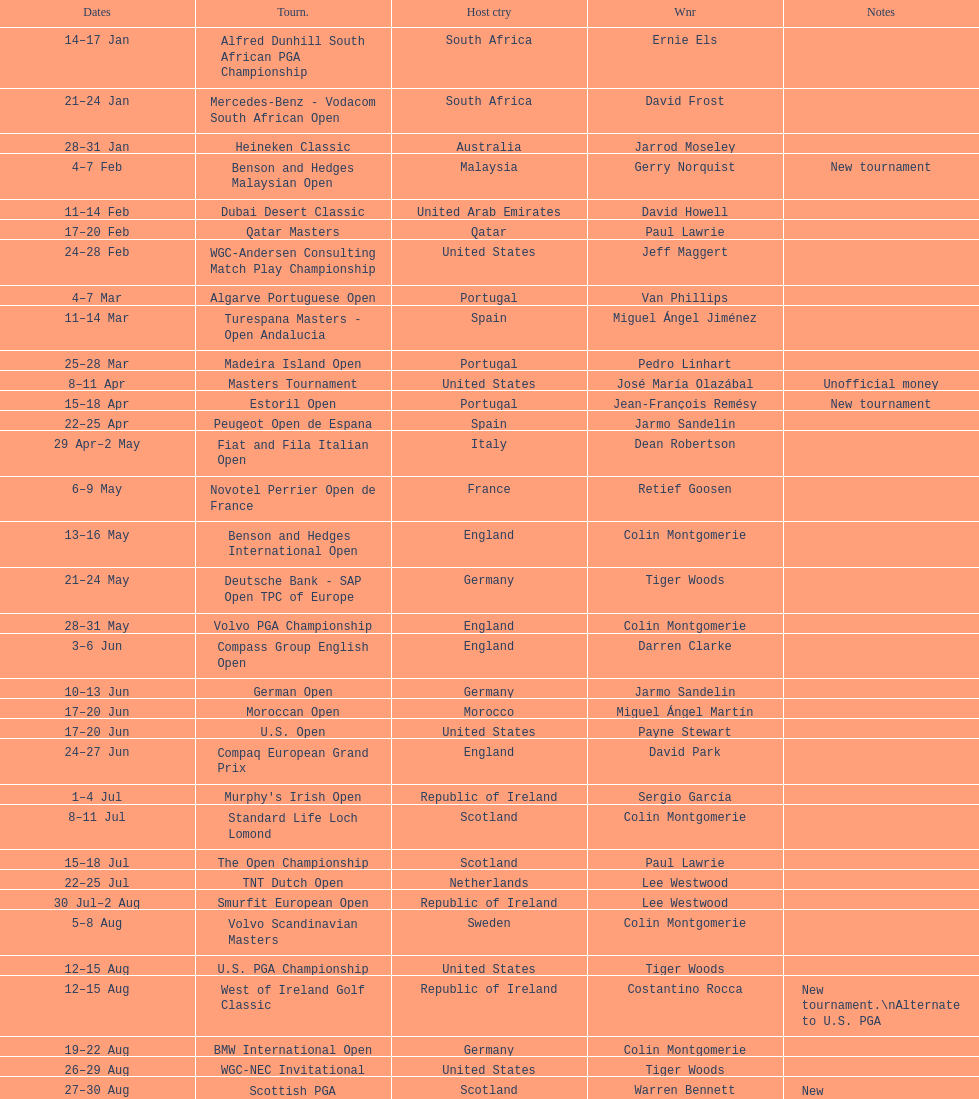Could you parse the entire table? {'header': ['Dates', 'Tourn.', 'Host ctry', 'Wnr', 'Notes'], 'rows': [['14–17\xa0Jan', 'Alfred Dunhill South African PGA Championship', 'South Africa', 'Ernie Els', ''], ['21–24\xa0Jan', 'Mercedes-Benz - Vodacom South African Open', 'South Africa', 'David Frost', ''], ['28–31\xa0Jan', 'Heineken Classic', 'Australia', 'Jarrod Moseley', ''], ['4–7\xa0Feb', 'Benson and Hedges Malaysian Open', 'Malaysia', 'Gerry Norquist', 'New tournament'], ['11–14\xa0Feb', 'Dubai Desert Classic', 'United Arab Emirates', 'David Howell', ''], ['17–20\xa0Feb', 'Qatar Masters', 'Qatar', 'Paul Lawrie', ''], ['24–28\xa0Feb', 'WGC-Andersen Consulting Match Play Championship', 'United States', 'Jeff Maggert', ''], ['4–7\xa0Mar', 'Algarve Portuguese Open', 'Portugal', 'Van Phillips', ''], ['11–14\xa0Mar', 'Turespana Masters - Open Andalucia', 'Spain', 'Miguel Ángel Jiménez', ''], ['25–28\xa0Mar', 'Madeira Island Open', 'Portugal', 'Pedro Linhart', ''], ['8–11\xa0Apr', 'Masters Tournament', 'United States', 'José María Olazábal', 'Unofficial money'], ['15–18\xa0Apr', 'Estoril Open', 'Portugal', 'Jean-François Remésy', 'New tournament'], ['22–25\xa0Apr', 'Peugeot Open de Espana', 'Spain', 'Jarmo Sandelin', ''], ['29\xa0Apr–2\xa0May', 'Fiat and Fila Italian Open', 'Italy', 'Dean Robertson', ''], ['6–9\xa0May', 'Novotel Perrier Open de France', 'France', 'Retief Goosen', ''], ['13–16\xa0May', 'Benson and Hedges International Open', 'England', 'Colin Montgomerie', ''], ['21–24\xa0May', 'Deutsche Bank - SAP Open TPC of Europe', 'Germany', 'Tiger Woods', ''], ['28–31\xa0May', 'Volvo PGA Championship', 'England', 'Colin Montgomerie', ''], ['3–6\xa0Jun', 'Compass Group English Open', 'England', 'Darren Clarke', ''], ['10–13\xa0Jun', 'German Open', 'Germany', 'Jarmo Sandelin', ''], ['17–20\xa0Jun', 'Moroccan Open', 'Morocco', 'Miguel Ángel Martín', ''], ['17–20\xa0Jun', 'U.S. Open', 'United States', 'Payne Stewart', ''], ['24–27\xa0Jun', 'Compaq European Grand Prix', 'England', 'David Park', ''], ['1–4\xa0Jul', "Murphy's Irish Open", 'Republic of Ireland', 'Sergio García', ''], ['8–11\xa0Jul', 'Standard Life Loch Lomond', 'Scotland', 'Colin Montgomerie', ''], ['15–18\xa0Jul', 'The Open Championship', 'Scotland', 'Paul Lawrie', ''], ['22–25\xa0Jul', 'TNT Dutch Open', 'Netherlands', 'Lee Westwood', ''], ['30\xa0Jul–2\xa0Aug', 'Smurfit European Open', 'Republic of Ireland', 'Lee Westwood', ''], ['5–8\xa0Aug', 'Volvo Scandinavian Masters', 'Sweden', 'Colin Montgomerie', ''], ['12–15\xa0Aug', 'U.S. PGA Championship', 'United States', 'Tiger Woods', ''], ['12–15\xa0Aug', 'West of Ireland Golf Classic', 'Republic of Ireland', 'Costantino Rocca', 'New tournament.\\nAlternate to U.S. PGA'], ['19–22\xa0Aug', 'BMW International Open', 'Germany', 'Colin Montgomerie', ''], ['26–29\xa0Aug', 'WGC-NEC Invitational', 'United States', 'Tiger Woods', ''], ['27–30\xa0Aug', 'Scottish PGA Championship', 'Scotland', 'Warren Bennett', 'New tournament.\\nAlternate to WGC'], ['2–5\xa0Sept', 'Canon European Masters', 'Switzerland', 'Lee Westwood', ''], ['9–12\xa0Sept', 'Victor Chandler British Masters', 'England', 'Bob May', ''], ['16–19\xa0Sept', 'Trophée Lancôme', 'France', 'Pierre Fulke', ''], ['24–27\xa0Sept', 'Ryder Cup', 'United States', 'United States', 'Team event'], ['30\xa0Sept–3\xa0Oct', 'Linde German Masters', 'Germany', 'Sergio García', ''], ['7–10\xa0Oct', 'Alfred Dunhill Cup', 'Scotland', 'Spain', 'Team event.\\nUnofficial money'], ['14–17\xa0Oct', 'Cisco World Match Play Championship', 'England', 'Colin Montgomerie', 'Unofficial money'], ['14–17\xa0Oct', 'Sarazen World Open', 'Spain', 'Thomas Bjørn', 'New tournament'], ['21–24\xa0Oct', 'Belgacom Open', 'Belgium', 'Robert Karlsson', ''], ['28–31\xa0Oct', 'Volvo Masters', 'Spain', 'Miguel Ángel Jiménez', ''], ['4–7\xa0Nov', 'WGC-American Express Championship', 'Spain', 'Tiger Woods', ''], ['18–21\xa0Nov', 'World Cup of Golf', 'Malaysia', 'United States', 'Team event.\\nUnofficial money']]} Does any country have more than 5 winners? Yes. 